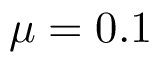<formula> <loc_0><loc_0><loc_500><loc_500>\mu = 0 . 1</formula> 